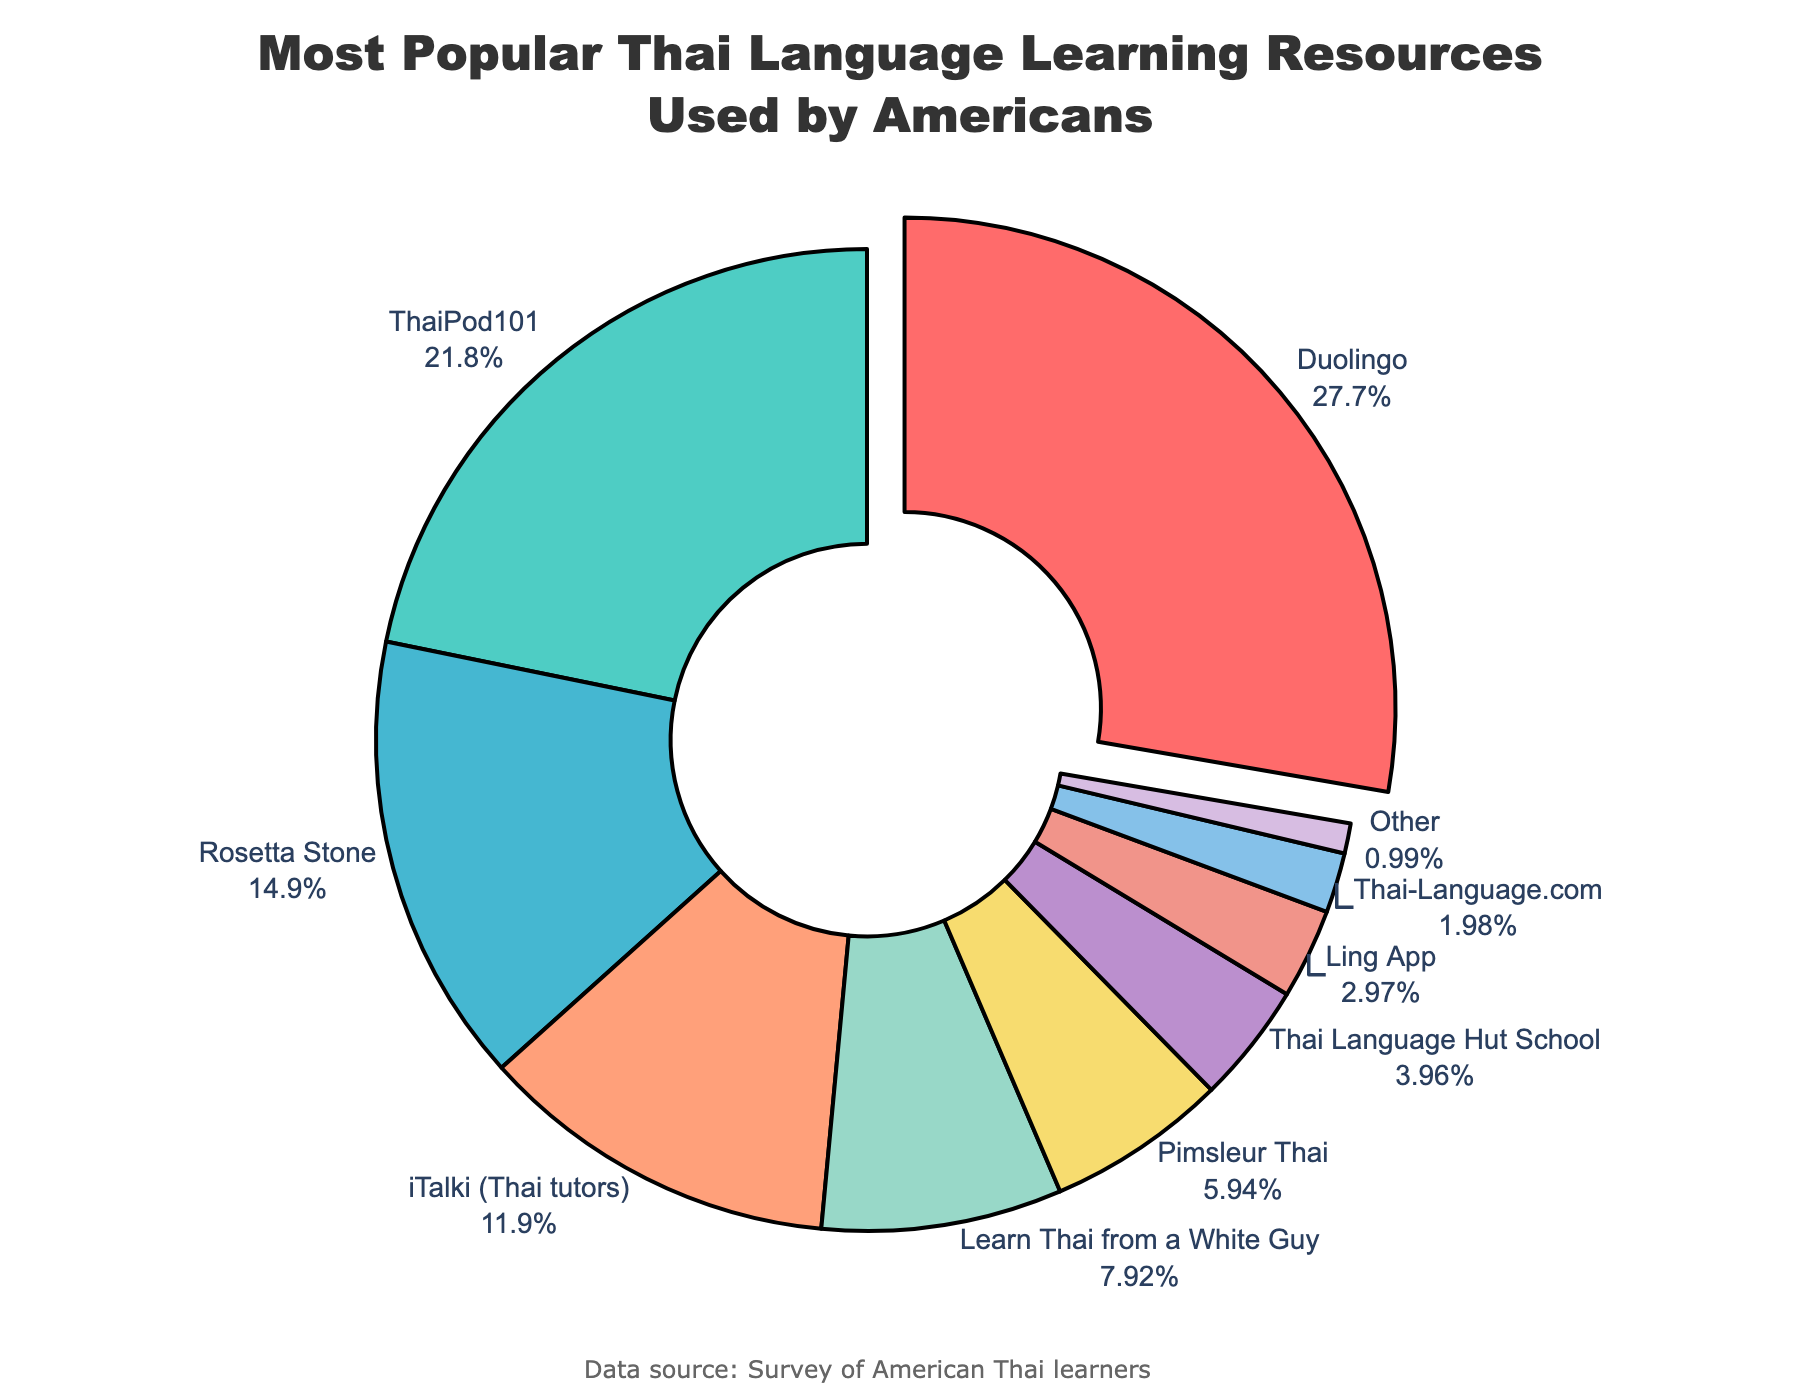Which Thai language learning resource is the most popular among Americans? The segmented pie chart shows different percentages for each resource. The segment with the highest percentage is Duolingo.
Answer: Duolingo Which Thai language learning resource has the second most users? The resources are listed with their respective percentages. ThaiPod101 has the second highest percentage after Duolingo.
Answer: ThaiPod101 What percentage of users use Rosetta Stone for learning Thai compared to the total? The pie chart indicates that Rosetta Stone comprises 15% of the users.
Answer: 15% What is the total percentage of learners using resources other than Duolingo, ThaiPod101, and Rosetta Stone? Add the percentages of all other resources: iTalki (12%) + Learn Thai from a White Guy (8%) + Pimsleur Thai (6%) + Thai Language Hut School (4%) + Ling App (3%) + Thai-Language.com (2%) + Other (1%). The total is 36%.
Answer: 36% How much more popular is Duolingo than ThaiPod101 for learning Thai? Duolingo has a percentage of 28% compared to ThaiPod101's 22%. The difference is 28% - 22% = 6%.
Answer: 6% Which Thai language learning resource is represented by the smallest segment? The pie chart shows "Other" with the smallest segment, indicating it is the least used at 1%.
Answer: Other What is the combined percentage of users using iTalki and Learn Thai from a White Guy? Add the percentages for iTalki (12%) and Learn Thai from a White Guy (8%). The combined percentage is 12% + 8% = 20%.
Answer: 20% Among the lesser-used resources (those with 5% or less), what is the total proportion? Sum the percentages of Thai Language Hut School (4%), Ling App (3%), and Thai-Language.com (2%). The total is 4% + 3% + 2% = 9%.
Answer: 9% Which color represents the Learn Thai from a White Guy resource on the pie chart? The pie chart color for Learn Thai from a White Guy is identified as a segment with the corresponding percentage of 8%. It is depicted in #F1948A (light red).
Answer: Light red By how much does the percentage of Duolingo users exceed the combined percentages of Pimsleur Thai and Thai Language Hut School? Sum the percentages of Pimsleur Thai (6%) and Thai Language Hut School (4%), which equals 10%. Duolingo's percentage is 28%, so the difference is 28% - 10% = 18%.
Answer: 18% 